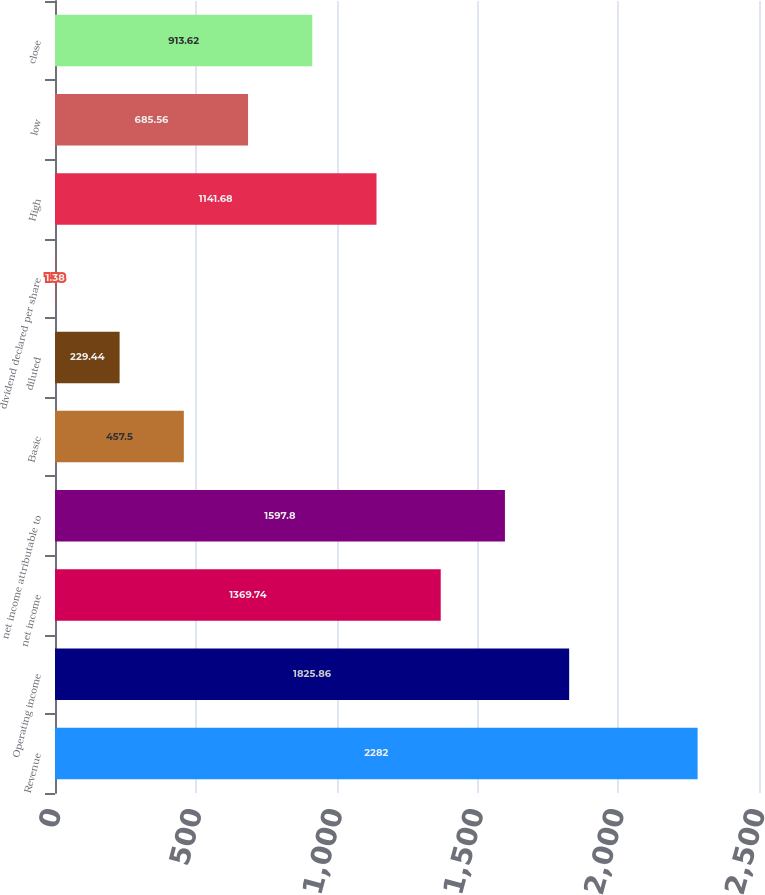Convert chart to OTSL. <chart><loc_0><loc_0><loc_500><loc_500><bar_chart><fcel>Revenue<fcel>Operating income<fcel>net income<fcel>net income attributable to<fcel>Basic<fcel>diluted<fcel>dividend declared per share<fcel>High<fcel>low<fcel>close<nl><fcel>2282<fcel>1825.86<fcel>1369.74<fcel>1597.8<fcel>457.5<fcel>229.44<fcel>1.38<fcel>1141.68<fcel>685.56<fcel>913.62<nl></chart> 